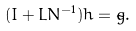Convert formula to latex. <formula><loc_0><loc_0><loc_500><loc_500>( I + L N ^ { - 1 } ) h = \tilde { g } .</formula> 